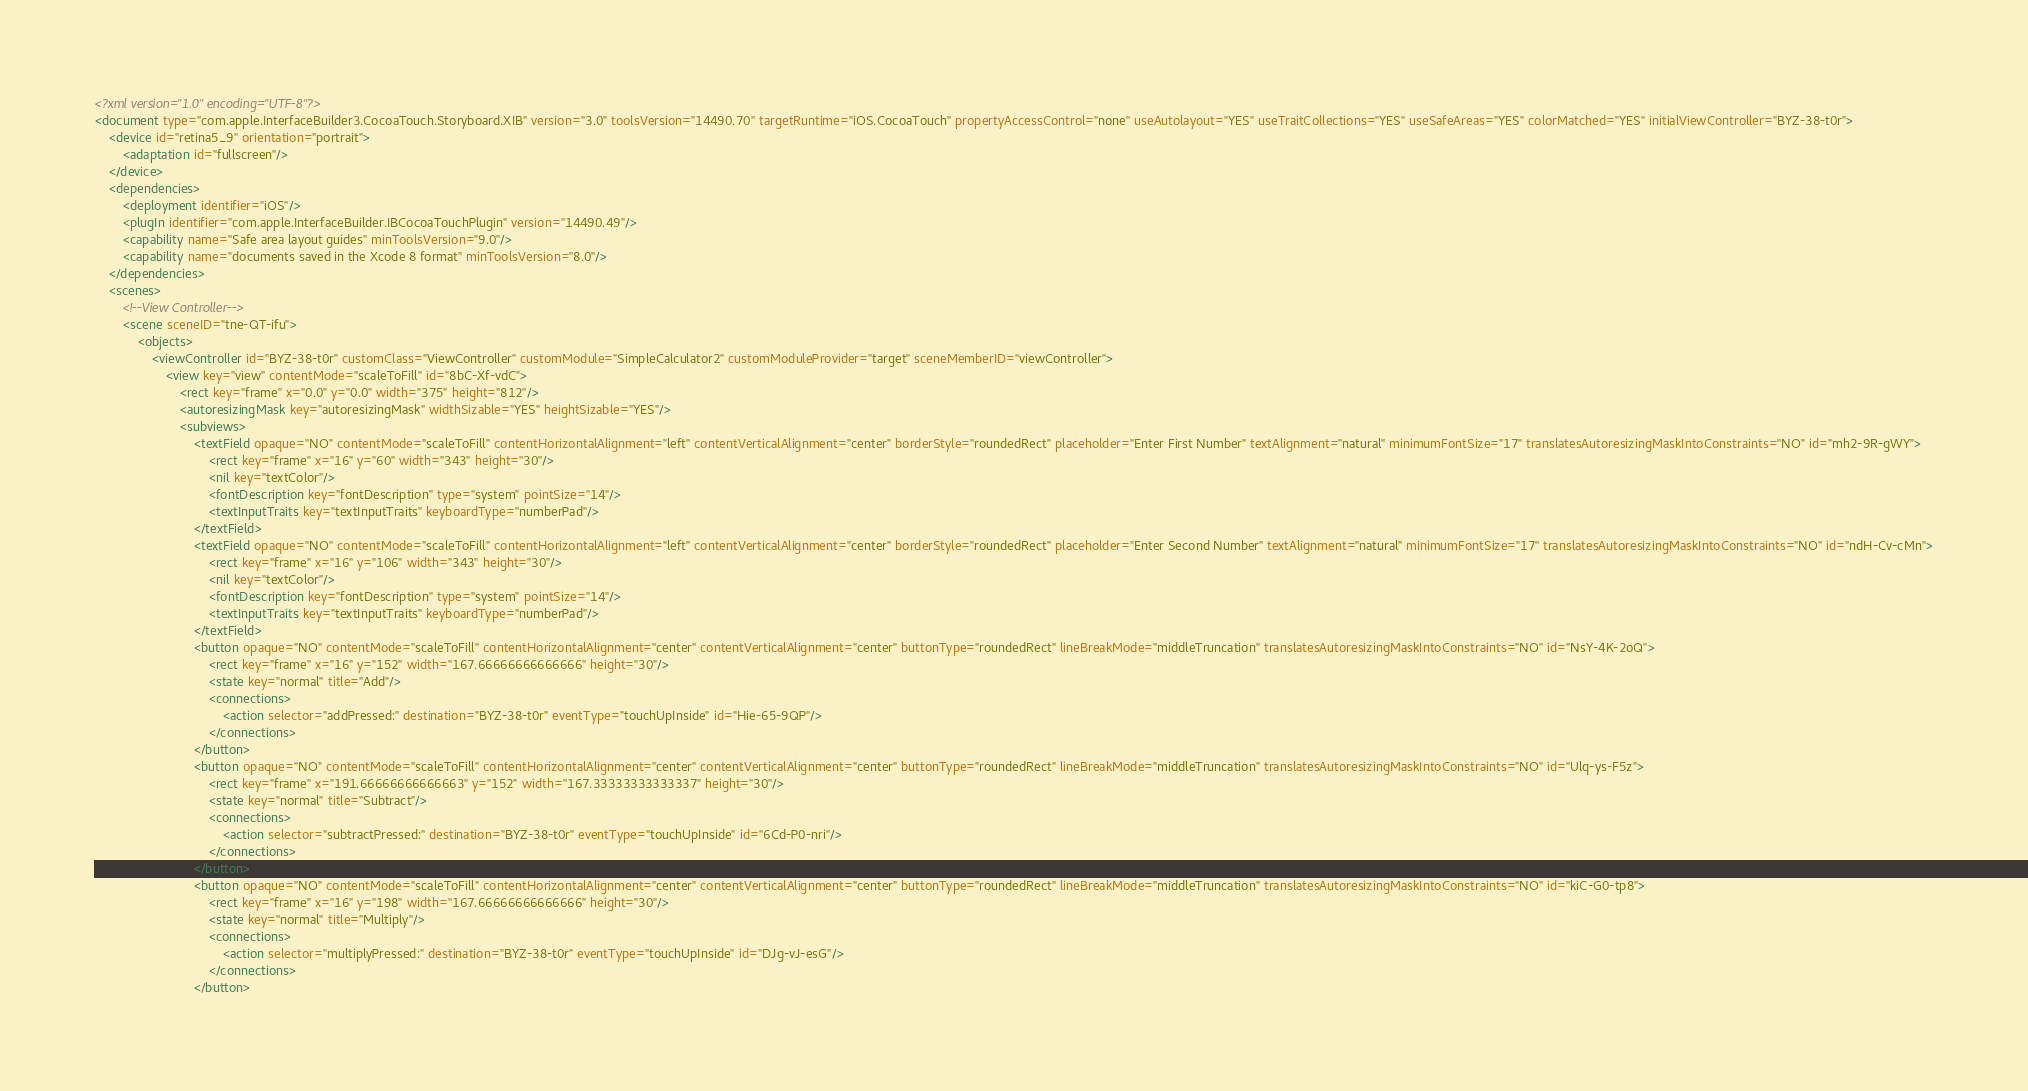<code> <loc_0><loc_0><loc_500><loc_500><_XML_><?xml version="1.0" encoding="UTF-8"?>
<document type="com.apple.InterfaceBuilder3.CocoaTouch.Storyboard.XIB" version="3.0" toolsVersion="14490.70" targetRuntime="iOS.CocoaTouch" propertyAccessControl="none" useAutolayout="YES" useTraitCollections="YES" useSafeAreas="YES" colorMatched="YES" initialViewController="BYZ-38-t0r">
    <device id="retina5_9" orientation="portrait">
        <adaptation id="fullscreen"/>
    </device>
    <dependencies>
        <deployment identifier="iOS"/>
        <plugIn identifier="com.apple.InterfaceBuilder.IBCocoaTouchPlugin" version="14490.49"/>
        <capability name="Safe area layout guides" minToolsVersion="9.0"/>
        <capability name="documents saved in the Xcode 8 format" minToolsVersion="8.0"/>
    </dependencies>
    <scenes>
        <!--View Controller-->
        <scene sceneID="tne-QT-ifu">
            <objects>
                <viewController id="BYZ-38-t0r" customClass="ViewController" customModule="SimpleCalculator2" customModuleProvider="target" sceneMemberID="viewController">
                    <view key="view" contentMode="scaleToFill" id="8bC-Xf-vdC">
                        <rect key="frame" x="0.0" y="0.0" width="375" height="812"/>
                        <autoresizingMask key="autoresizingMask" widthSizable="YES" heightSizable="YES"/>
                        <subviews>
                            <textField opaque="NO" contentMode="scaleToFill" contentHorizontalAlignment="left" contentVerticalAlignment="center" borderStyle="roundedRect" placeholder="Enter First Number" textAlignment="natural" minimumFontSize="17" translatesAutoresizingMaskIntoConstraints="NO" id="mh2-9R-gWY">
                                <rect key="frame" x="16" y="60" width="343" height="30"/>
                                <nil key="textColor"/>
                                <fontDescription key="fontDescription" type="system" pointSize="14"/>
                                <textInputTraits key="textInputTraits" keyboardType="numberPad"/>
                            </textField>
                            <textField opaque="NO" contentMode="scaleToFill" contentHorizontalAlignment="left" contentVerticalAlignment="center" borderStyle="roundedRect" placeholder="Enter Second Number" textAlignment="natural" minimumFontSize="17" translatesAutoresizingMaskIntoConstraints="NO" id="ndH-Cv-cMn">
                                <rect key="frame" x="16" y="106" width="343" height="30"/>
                                <nil key="textColor"/>
                                <fontDescription key="fontDescription" type="system" pointSize="14"/>
                                <textInputTraits key="textInputTraits" keyboardType="numberPad"/>
                            </textField>
                            <button opaque="NO" contentMode="scaleToFill" contentHorizontalAlignment="center" contentVerticalAlignment="center" buttonType="roundedRect" lineBreakMode="middleTruncation" translatesAutoresizingMaskIntoConstraints="NO" id="NsY-4K-2oQ">
                                <rect key="frame" x="16" y="152" width="167.66666666666666" height="30"/>
                                <state key="normal" title="Add"/>
                                <connections>
                                    <action selector="addPressed:" destination="BYZ-38-t0r" eventType="touchUpInside" id="Hie-65-9QP"/>
                                </connections>
                            </button>
                            <button opaque="NO" contentMode="scaleToFill" contentHorizontalAlignment="center" contentVerticalAlignment="center" buttonType="roundedRect" lineBreakMode="middleTruncation" translatesAutoresizingMaskIntoConstraints="NO" id="Ulq-ys-F5z">
                                <rect key="frame" x="191.66666666666663" y="152" width="167.33333333333337" height="30"/>
                                <state key="normal" title="Subtract"/>
                                <connections>
                                    <action selector="subtractPressed:" destination="BYZ-38-t0r" eventType="touchUpInside" id="6Cd-P0-nri"/>
                                </connections>
                            </button>
                            <button opaque="NO" contentMode="scaleToFill" contentHorizontalAlignment="center" contentVerticalAlignment="center" buttonType="roundedRect" lineBreakMode="middleTruncation" translatesAutoresizingMaskIntoConstraints="NO" id="kiC-G0-tp8">
                                <rect key="frame" x="16" y="198" width="167.66666666666666" height="30"/>
                                <state key="normal" title="Multiply"/>
                                <connections>
                                    <action selector="multiplyPressed:" destination="BYZ-38-t0r" eventType="touchUpInside" id="DJg-vJ-esG"/>
                                </connections>
                            </button></code> 